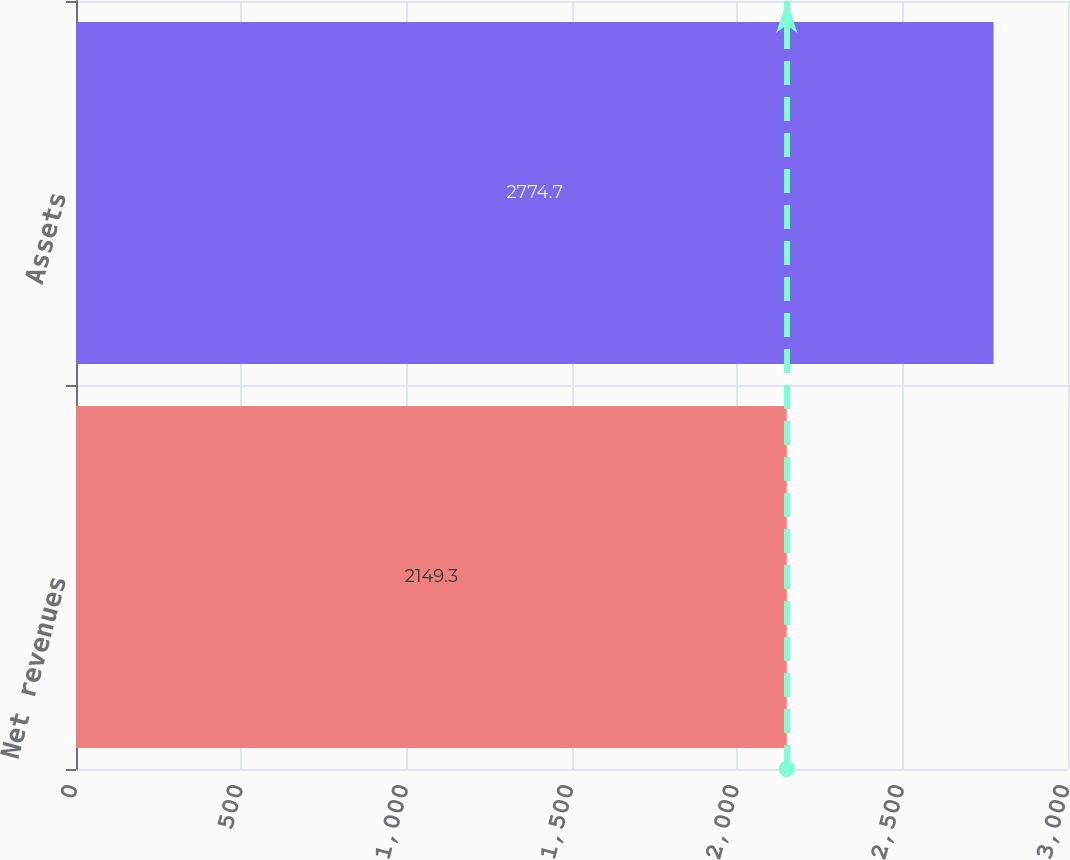<chart> <loc_0><loc_0><loc_500><loc_500><bar_chart><fcel>Net revenues<fcel>Assets<nl><fcel>2149.3<fcel>2774.7<nl></chart> 